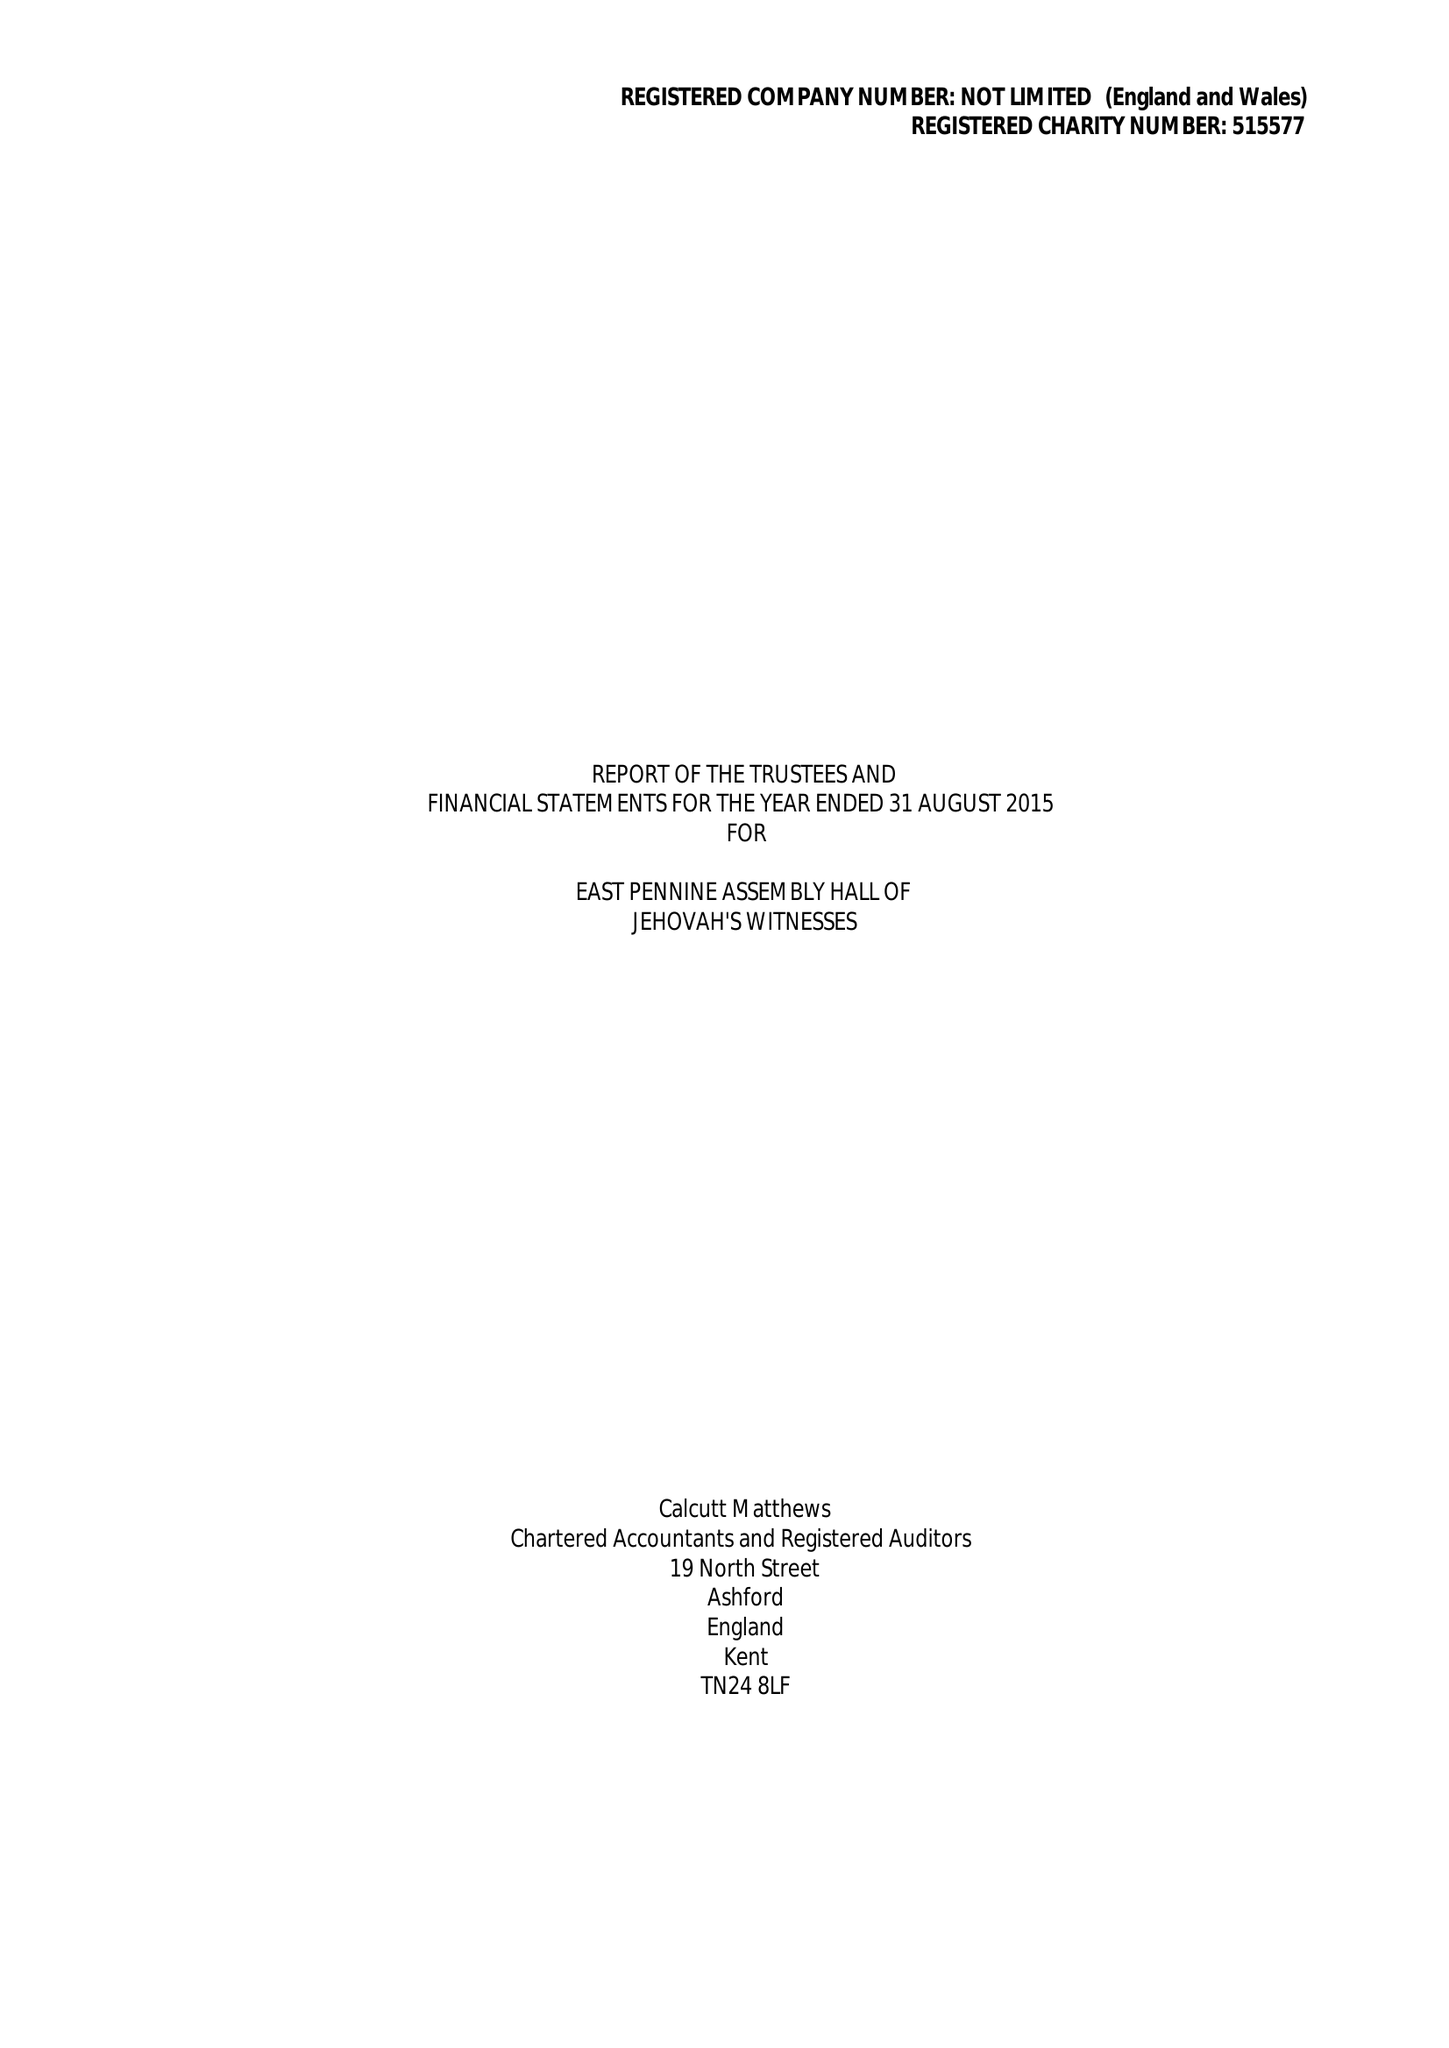What is the value for the income_annually_in_british_pounds?
Answer the question using a single word or phrase. 121511.00 